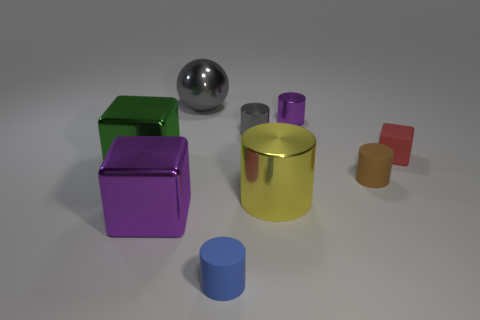Is there a gray cylinder of the same size as the blue object?
Keep it short and to the point. Yes. What is the color of the cylinder that is the same material as the small blue thing?
Your response must be concise. Brown. What is the small blue object made of?
Your answer should be compact. Rubber. The brown matte object has what shape?
Ensure brevity in your answer.  Cylinder. How many things have the same color as the big metallic sphere?
Offer a very short reply. 1. There is a cylinder that is to the right of the purple object that is on the right side of the small blue object that is left of the red cube; what is it made of?
Offer a terse response. Rubber. What number of green things are metallic blocks or balls?
Give a very brief answer. 1. How big is the gray thing in front of the shiny object on the right side of the big metallic thing that is right of the small blue cylinder?
Offer a very short reply. Small. What is the size of the other rubber thing that is the same shape as the green thing?
Make the answer very short. Small. What number of large things are red matte things or green rubber spheres?
Provide a short and direct response. 0. 